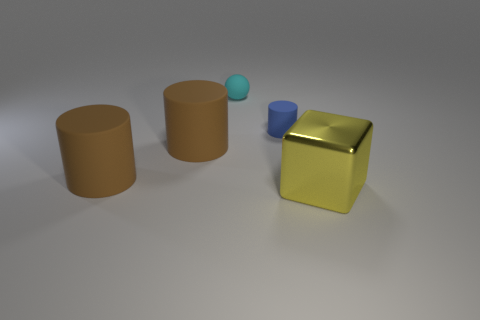The tiny object that is the same material as the tiny cyan sphere is what color? The small object composed of the same material as the tiny cyan-colored sphere depicted in the image has a blue hue, harmonizing with the sphere's color palette. 